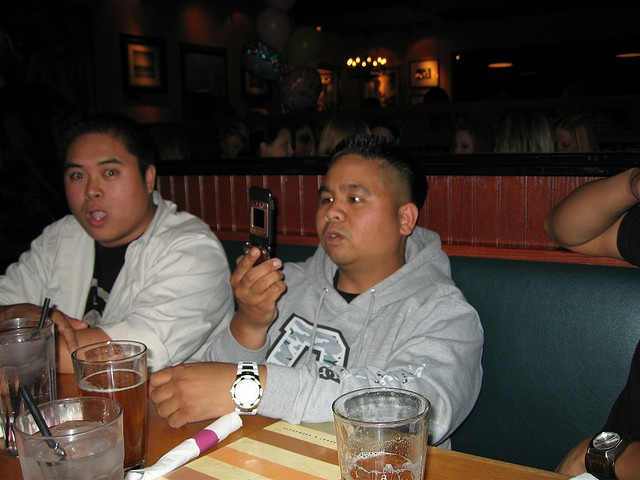Describe the objects in this image and their specific colors. I can see people in black, darkgray, brown, and gray tones, dining table in black, gray, maroon, and brown tones, people in black, darkgray, maroon, and brown tones, bench in black and purple tones, and cup in black, gray, and maroon tones in this image. 